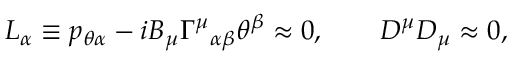<formula> <loc_0><loc_0><loc_500><loc_500>L _ { \alpha } \equiv p _ { \theta \alpha } - i B _ { \mu } { \Gamma ^ { \mu } } _ { \alpha \beta } \theta ^ { \beta } \approx 0 , \quad D ^ { \mu } D _ { \mu } \approx 0 ,</formula> 